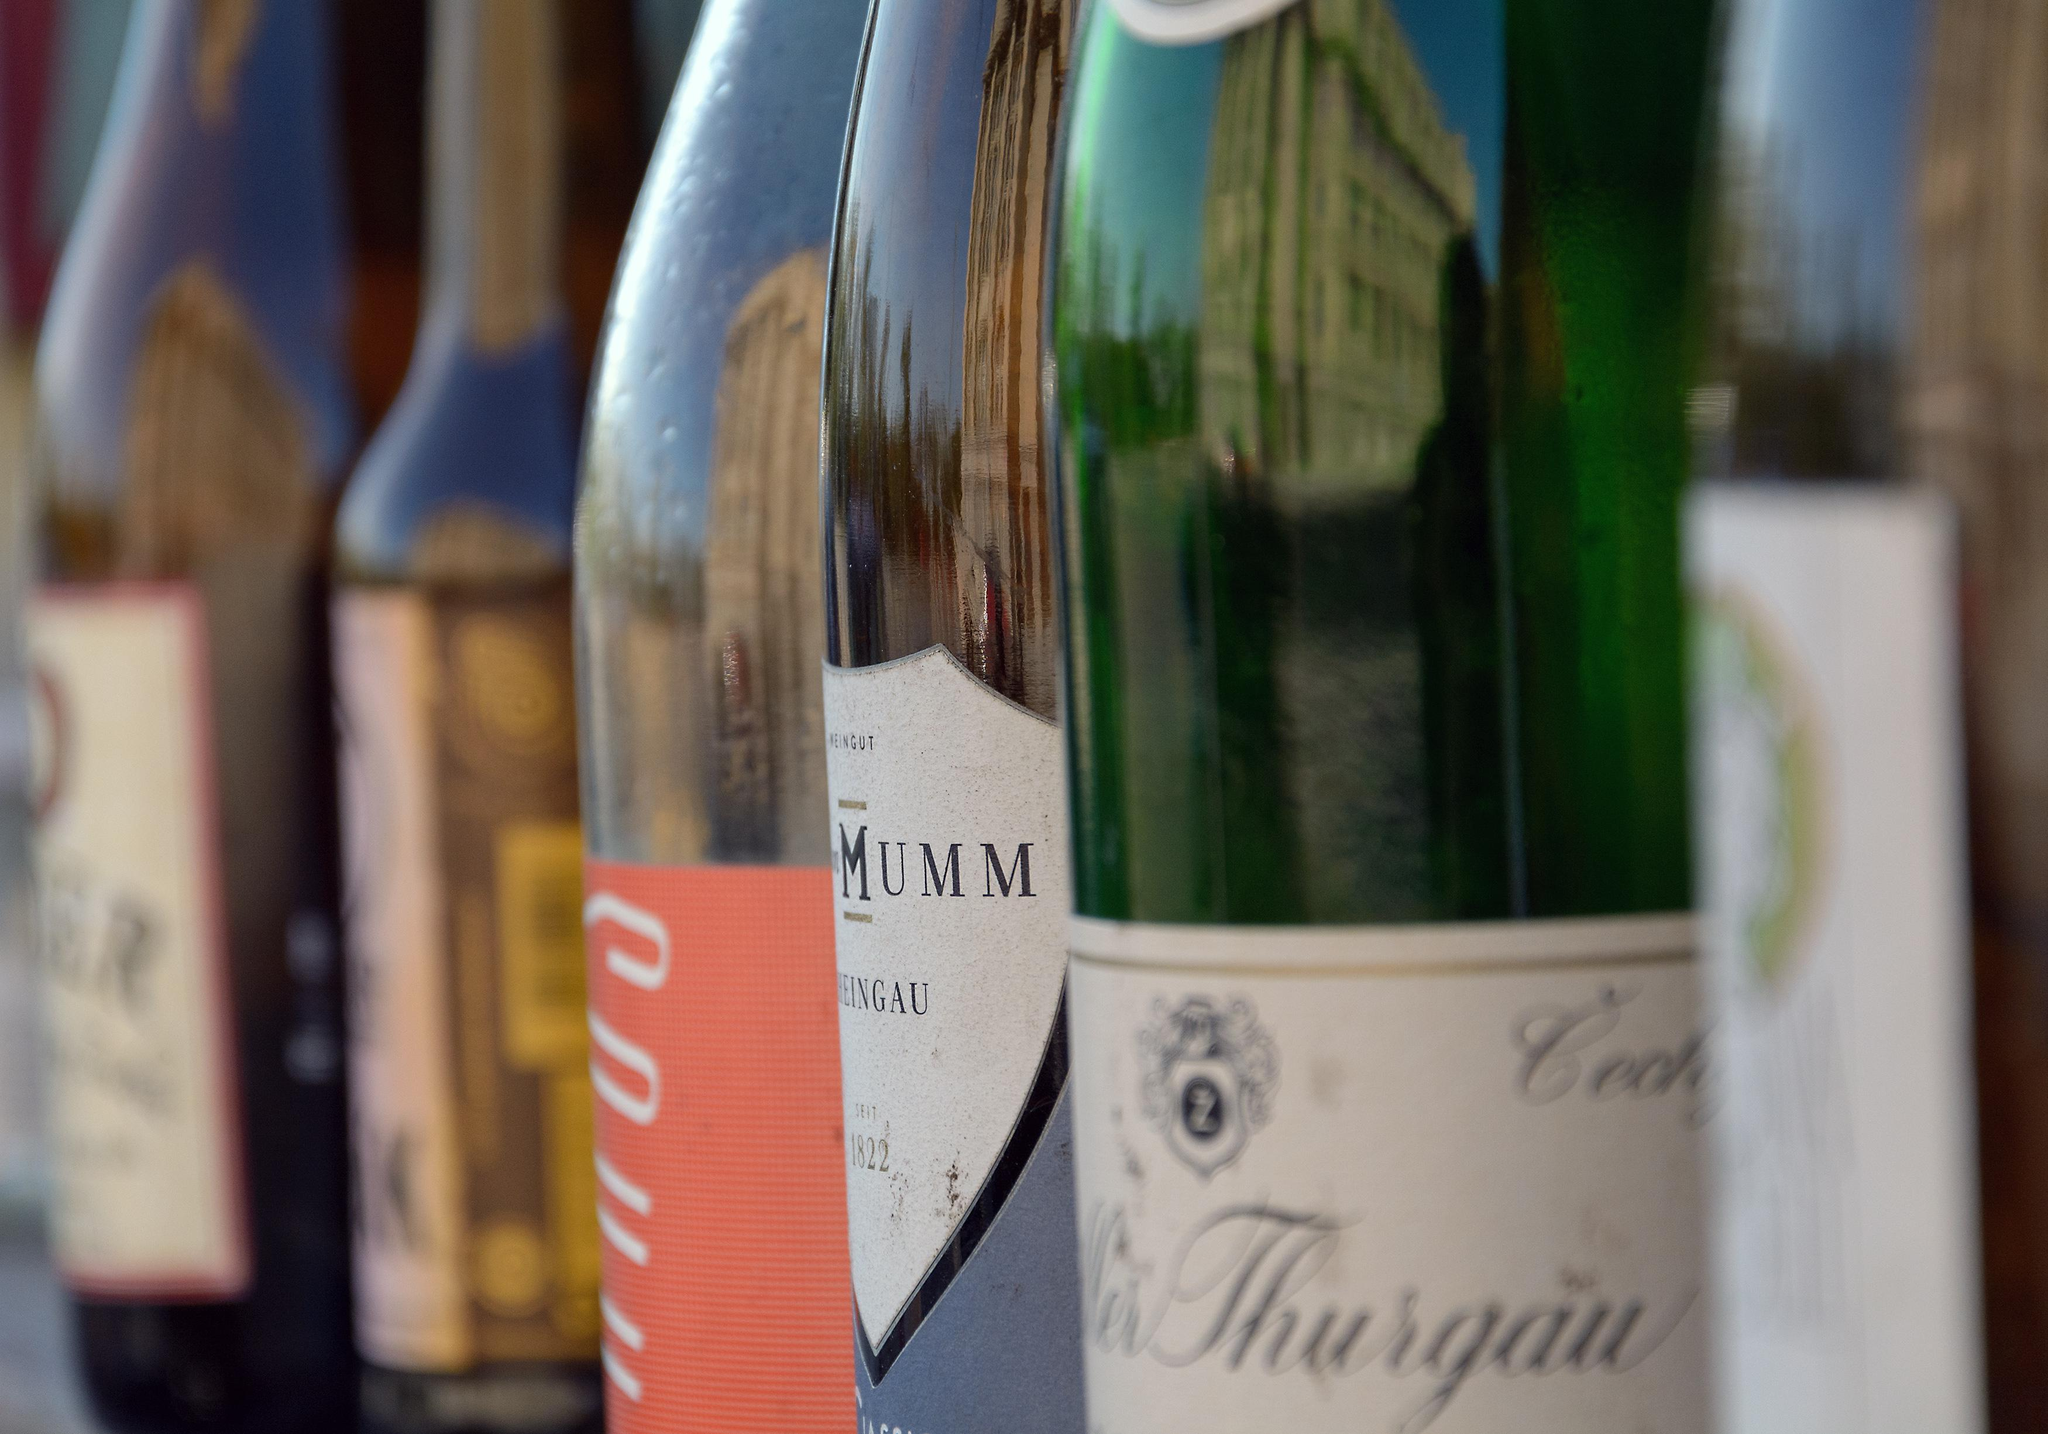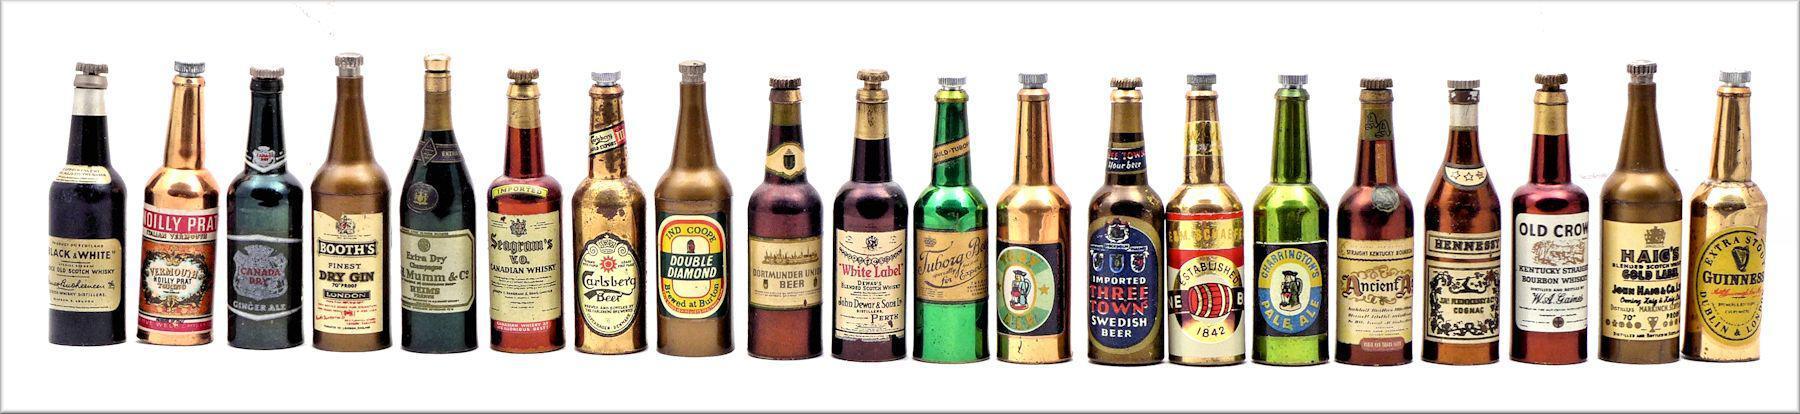The first image is the image on the left, the second image is the image on the right. Given the left and right images, does the statement "There are more bottles in the right image than in the left image." hold true? Answer yes or no. Yes. 